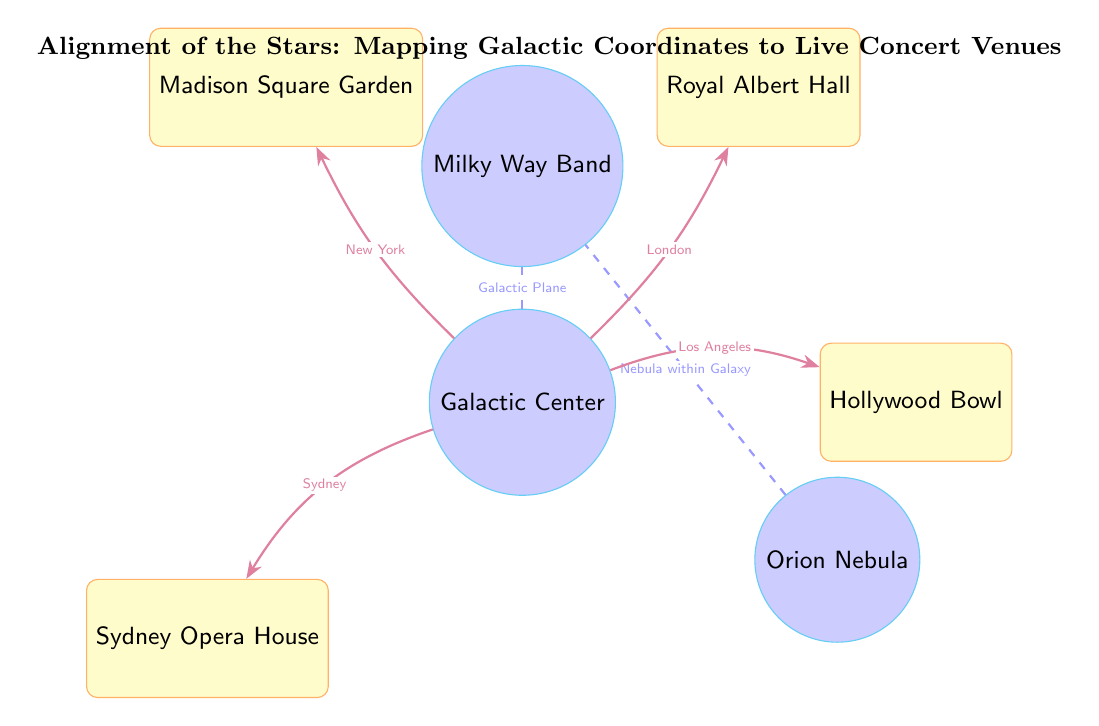What are the names of the celestial nodes in the diagram? The diagram has three celestial nodes identified as Galactic Center, Orion Nebula, and Milky Way Band.
Answer: Galactic Center, Orion Nebula, Milky Way Band How many concert venues are represented in the diagram? Each venue is a rectangle shape labeled in the diagram, and there are four distinct venues: Sydney Opera House, Madison Square Garden, Royal Albert Hall, and Hollywood Bowl.
Answer: 4 Which venue is associated with the city of Sydney? The diagram shows a connection from the Galactic Center labeled "Sydney" to the Sydney Opera House, indicating its association with Sydney.
Answer: Sydney Opera House What is the labeled connection between the Galactic Center and Madison Square Garden? The arrows in the diagram indicate a bend to the left from the Galactic Center towards Madison Square Garden, labeled "New York," indicating that the venue is related to that city.
Answer: New York Which celestial node is connected to both the Galactic Center and Orion Nebula? The diagram illustrates a direct relationship from the Galactic Center to the Milky Way Band, with the Orion Nebula also connecting to the Milky Way Band, but the key connection involving both is with the Galactic Plane.
Answer: Milky Way Band How does the Galactic Center connect to Hollywood Bowl? A bend to the left from the Galactic Center labeled "Los Angeles" leads to Hollywood Bowl, indicating the direct connection from the center to this venue.
Answer: Los Angeles What type of line connects the Galactic Center to the Milky Way Band? The line connecting these two nodes is dashed, indicating their relationship as part of the Galactic Plane in an astronomical context.
Answer: Dashed Which connection is labeled as representing a nebula within the galaxy? There is a dashed connection labeled "Nebula within Galaxy" between the Orion Nebula and the Milky Way Band, indicating that this connection is focused on the nebula's placement in relation to the galaxy.
Answer: Nebula within Galaxy What connects the Galactic Center to Royal Albert Hall? There is a connection showing a bend to the right from the Galactic Center labeled "London," which indicates the relationship between them leading to Royal Albert Hall.
Answer: London 